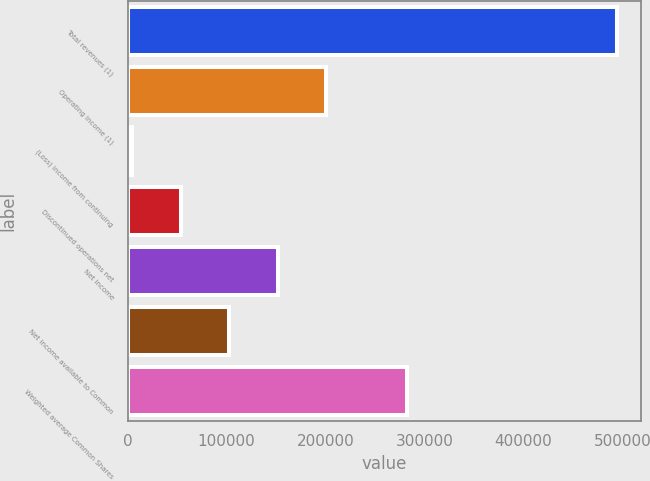Convert chart. <chart><loc_0><loc_0><loc_500><loc_500><bar_chart><fcel>Total revenues (1)<fcel>Operating income (1)<fcel>(Loss) income from continuing<fcel>Discontinued operations net<fcel>Net income<fcel>Net income available to Common<fcel>Weighted average Common Shares<nl><fcel>494541<fcel>200645<fcel>4714<fcel>53696.7<fcel>151662<fcel>102679<fcel>282217<nl></chart> 